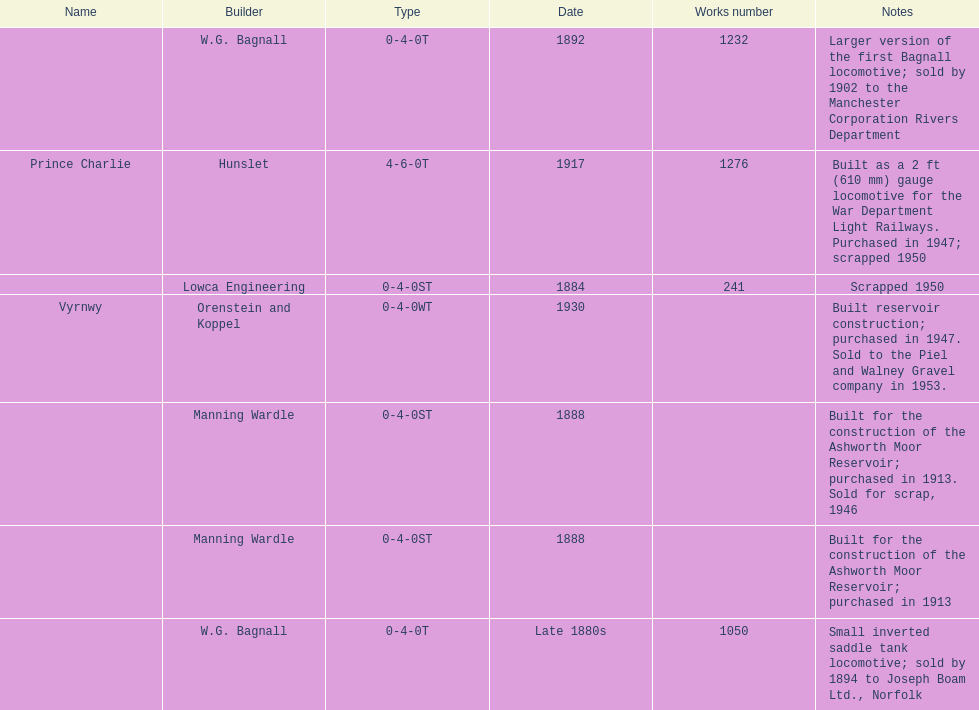Could you help me parse every detail presented in this table? {'header': ['Name', 'Builder', 'Type', 'Date', 'Works number', 'Notes'], 'rows': [['', 'W.G. Bagnall', '0-4-0T', '1892', '1232', 'Larger version of the first Bagnall locomotive; sold by 1902 to the Manchester Corporation Rivers Department'], ['Prince Charlie', 'Hunslet', '4-6-0T', '1917', '1276', 'Built as a 2\xa0ft (610\xa0mm) gauge locomotive for the War Department Light Railways. Purchased in 1947; scrapped 1950'], ['', 'Lowca Engineering', '0-4-0ST', '1884', '241', 'Scrapped 1950'], ['Vyrnwy', 'Orenstein and Koppel', '0-4-0WT', '1930', '', 'Built reservoir construction; purchased in 1947. Sold to the Piel and Walney Gravel company in 1953.'], ['', 'Manning Wardle', '0-4-0ST', '1888', '', 'Built for the construction of the Ashworth Moor Reservoir; purchased in 1913. Sold for scrap, 1946'], ['', 'Manning Wardle', '0-4-0ST', '1888', '', 'Built for the construction of the Ashworth Moor Reservoir; purchased in 1913'], ['', 'W.G. Bagnall', '0-4-0T', 'Late 1880s', '1050', 'Small inverted saddle tank locomotive; sold by 1894 to Joseph Boam Ltd., Norfolk']]} How many locomotives were scrapped? 3. 